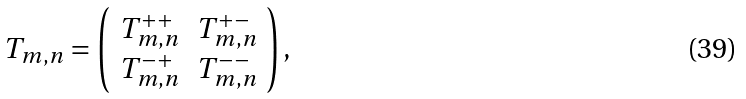Convert formula to latex. <formula><loc_0><loc_0><loc_500><loc_500>T _ { m , n } = \left ( \begin{array} { r r } T _ { m , n } ^ { + + } & T _ { m , n } ^ { + - } \\ T _ { m , n } ^ { - + } & T _ { m , n } ^ { - - } \end{array} \right ) ,</formula> 